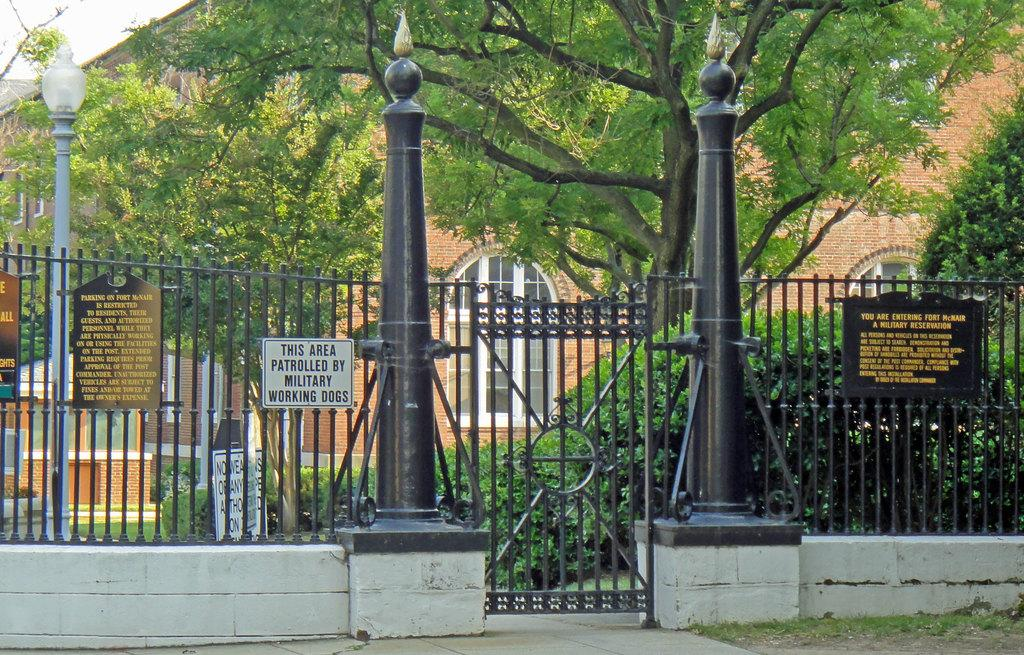What is the main structure in the middle of the image? There is a black color gate in the middle of the image. What can be seen in the background of the image? There are trees visible in the image. What type of building is present in the image? There is a big house in the image. How many pigs are running around the black color gate in the image? There are no pigs present in the image. What type of wind, zephyr, can be felt in the image? The image does not provide information about the weather or any wind, including zephyr. 